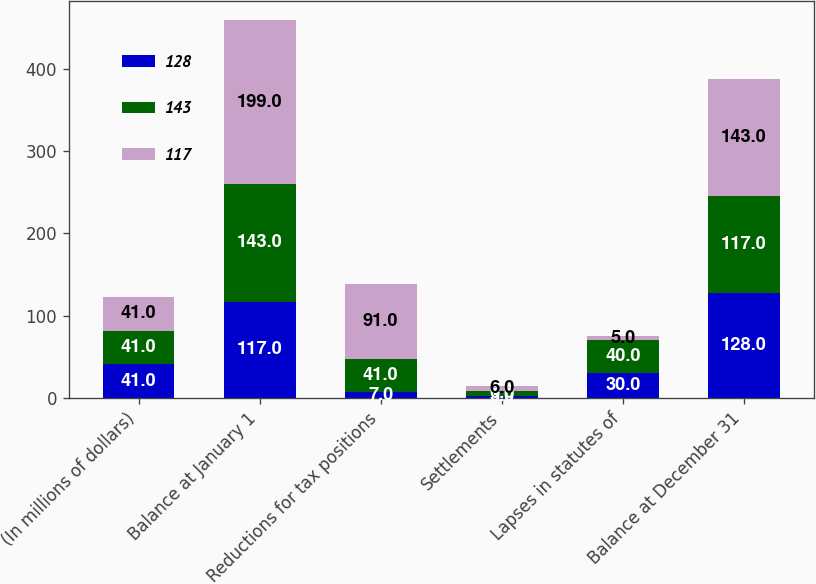Convert chart to OTSL. <chart><loc_0><loc_0><loc_500><loc_500><stacked_bar_chart><ecel><fcel>(In millions of dollars)<fcel>Balance at January 1<fcel>Reductions for tax positions<fcel>Settlements<fcel>Lapses in statutes of<fcel>Balance at December 31<nl><fcel>128<fcel>41<fcel>117<fcel>7<fcel>3<fcel>30<fcel>128<nl><fcel>143<fcel>41<fcel>143<fcel>41<fcel>6<fcel>40<fcel>117<nl><fcel>117<fcel>41<fcel>199<fcel>91<fcel>6<fcel>5<fcel>143<nl></chart> 